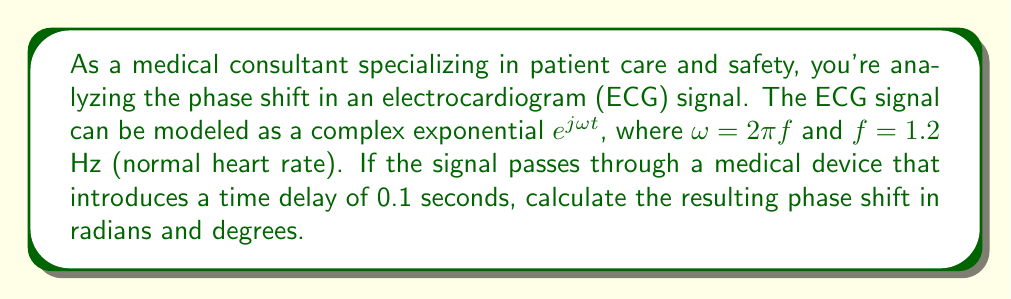Could you help me with this problem? To solve this problem, we'll follow these steps:

1) First, recall that a time delay $\tau$ in a signal $e^{j\omega t}$ results in a phase shift of $-\omega\tau$ radians.

2) We're given that $f = 1.2$ Hz. We need to convert this to angular frequency $\omega$:

   $\omega = 2\pi f = 2\pi(1.2) = 2.4\pi$ rad/s

3) The time delay $\tau$ is given as 0.1 seconds.

4) Now we can calculate the phase shift in radians:

   Phase shift $= -\omega\tau = -(2.4\pi)(0.1) = -0.24\pi$ radians

5) To convert this to degrees, we multiply by $\frac{180°}{\pi}$:

   Phase shift in degrees $= -0.24\pi \cdot \frac{180°}{\pi} = -43.2°$

The negative sign indicates that this is a phase lag, which is expected for a time delay.
Answer: The phase shift is $-0.24\pi$ radians or $-43.2°$. 